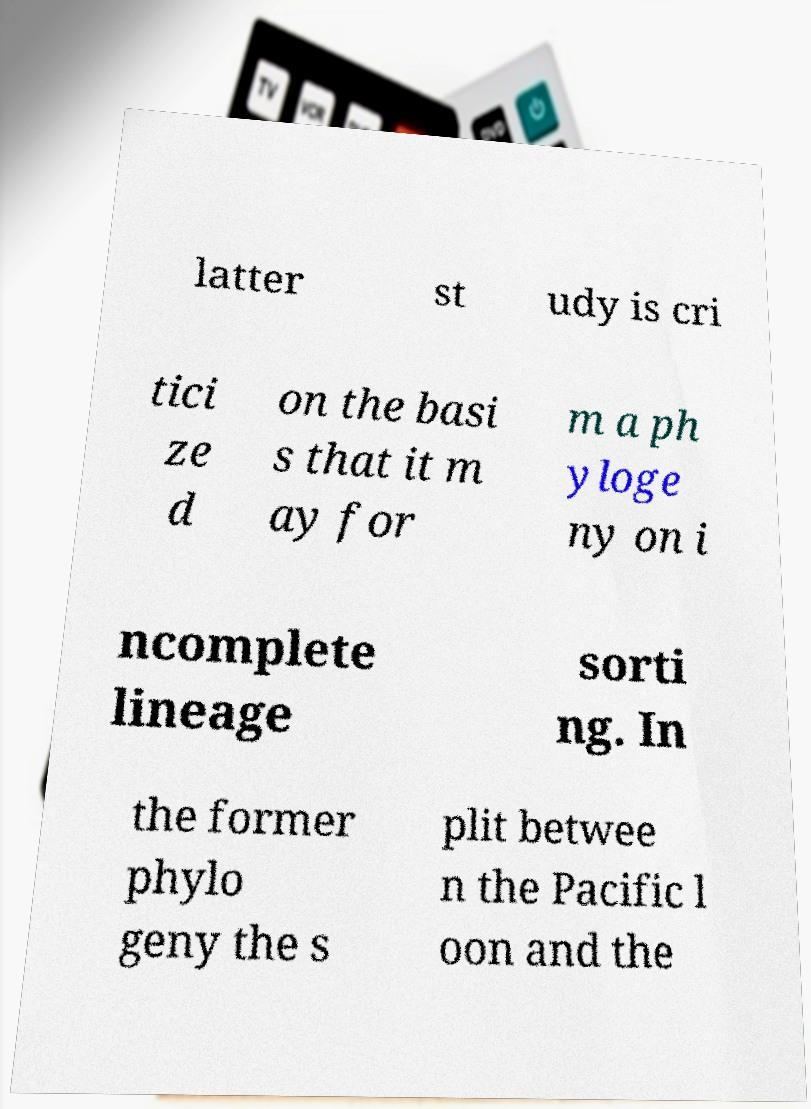Can you read and provide the text displayed in the image?This photo seems to have some interesting text. Can you extract and type it out for me? latter st udy is cri tici ze d on the basi s that it m ay for m a ph yloge ny on i ncomplete lineage sorti ng. In the former phylo geny the s plit betwee n the Pacific l oon and the 